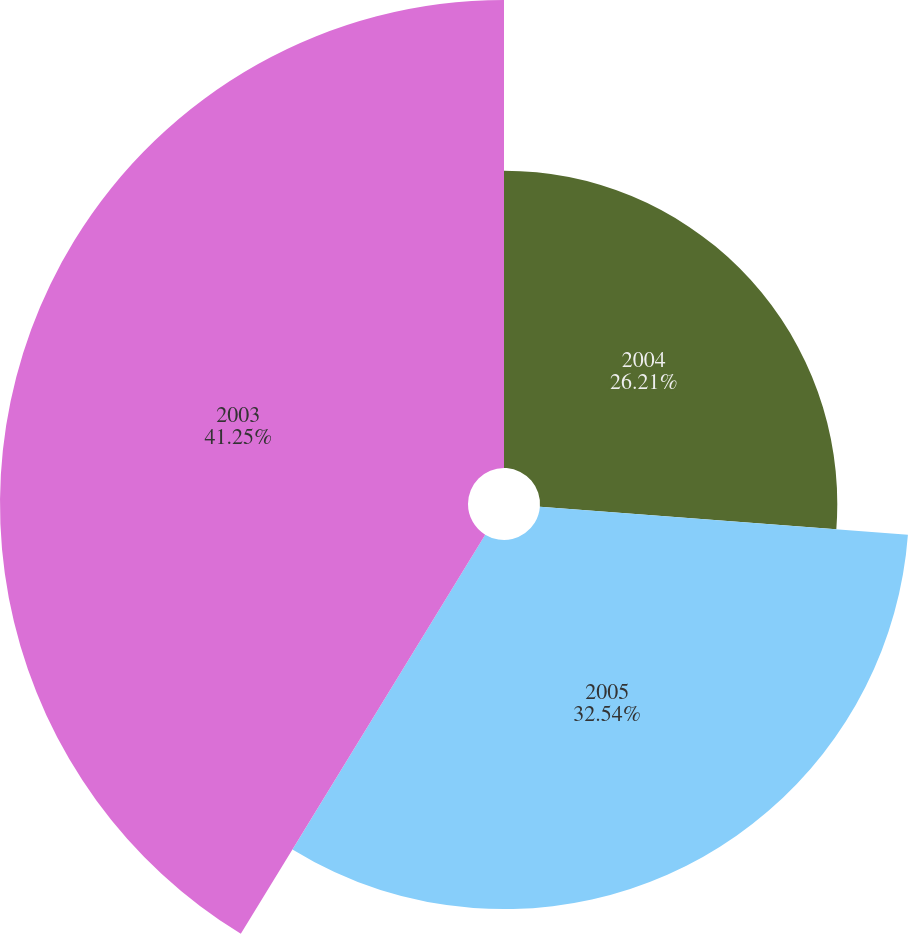Convert chart to OTSL. <chart><loc_0><loc_0><loc_500><loc_500><pie_chart><fcel>2004<fcel>2005<fcel>2003<nl><fcel>26.21%<fcel>32.54%<fcel>41.26%<nl></chart> 